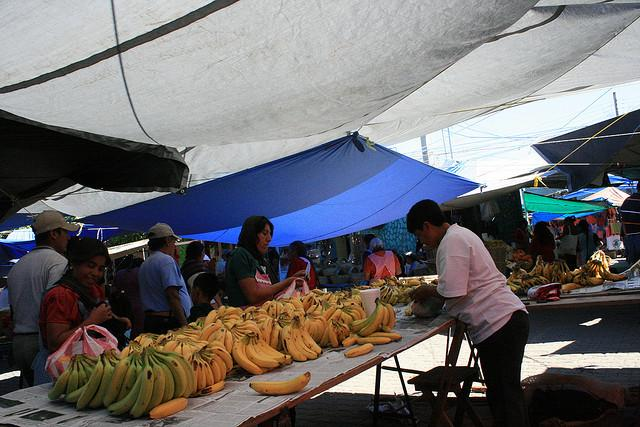Encouraging what American Ice cream treat is an obvious choice for these vendors?

Choices:
A) banana split
B) chocolate malt
C) chocolate sundae
D) brownie cake banana split 